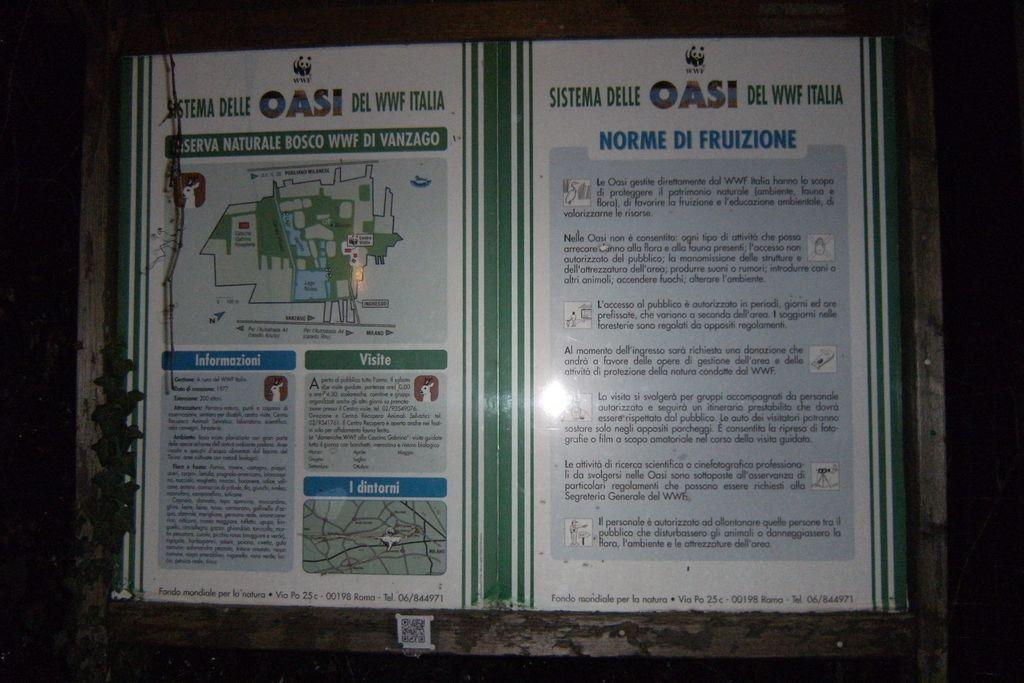<image>
Write a terse but informative summary of the picture. Two posters titled OASI describe a natural park 